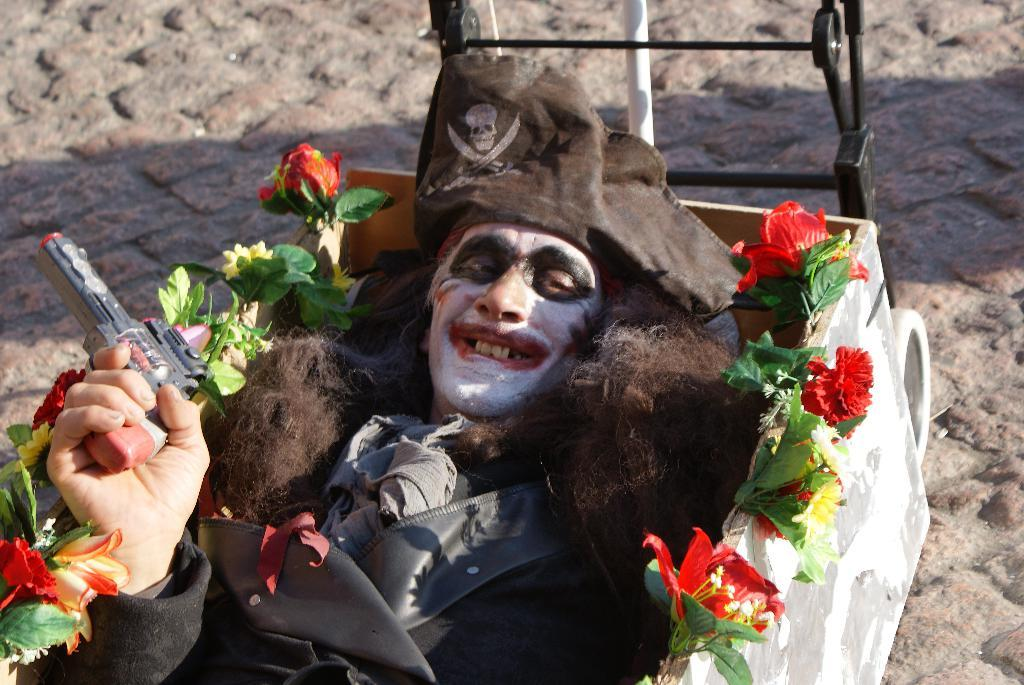Who is the main subject in the image? There is a man in the center of the image. What is the man holding in the image? The man is holding a gun. Where is the gun located in the image? The gun is in a box. What decorative elements are present around the box? There are flowers around the box. What is the man's belief about the tiger in the image? There is no tiger present in the image, so it is not possible to determine the man's belief about a tiger. 